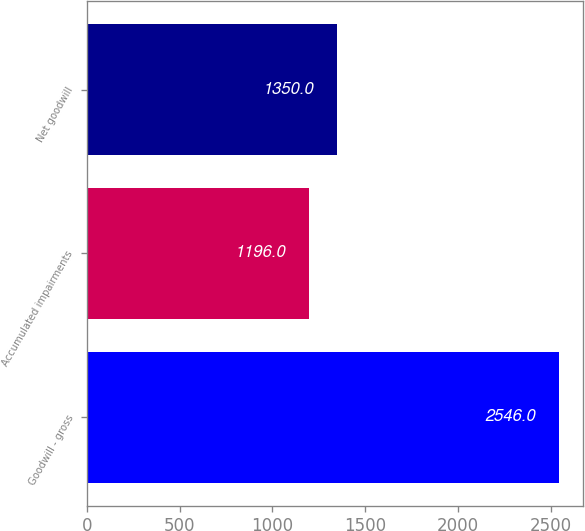Convert chart to OTSL. <chart><loc_0><loc_0><loc_500><loc_500><bar_chart><fcel>Goodwill - gross<fcel>Accumulated impairments<fcel>Net goodwill<nl><fcel>2546<fcel>1196<fcel>1350<nl></chart> 